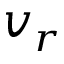Convert formula to latex. <formula><loc_0><loc_0><loc_500><loc_500>v _ { r }</formula> 